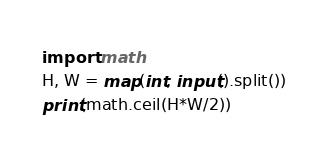<code> <loc_0><loc_0><loc_500><loc_500><_Python_>import math
H, W = map(int, input().split())
print(math.ceil(H*W/2))</code> 